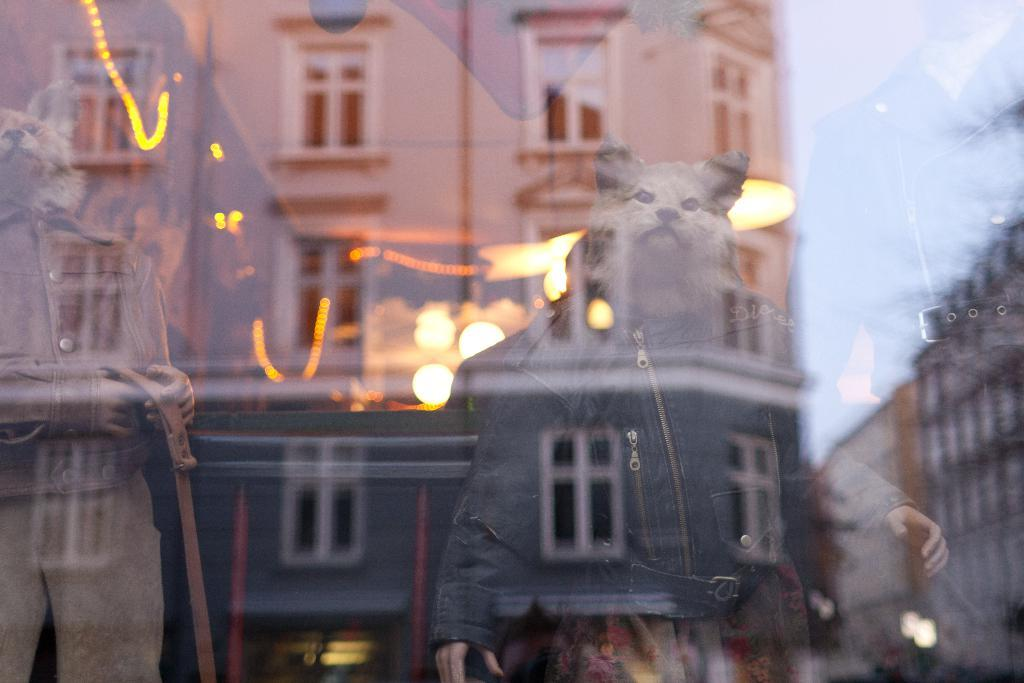What type of dolls are in the image? There are mannequin dolls in the image. What distinguishing feature do the dolls have? The mannequin dolls have animal faces. What are the dolls wearing? The mannequin dolls are wearing dresses. What else can be seen in the image besides the dolls? There is a glass in the image. What is reflected in the glass? The glass reflects buildings and the sky. What type of seed can be seen growing in the image? There is no seed or plant visible in the image; it features mannequin dolls and a glass reflecting buildings and the sky. 